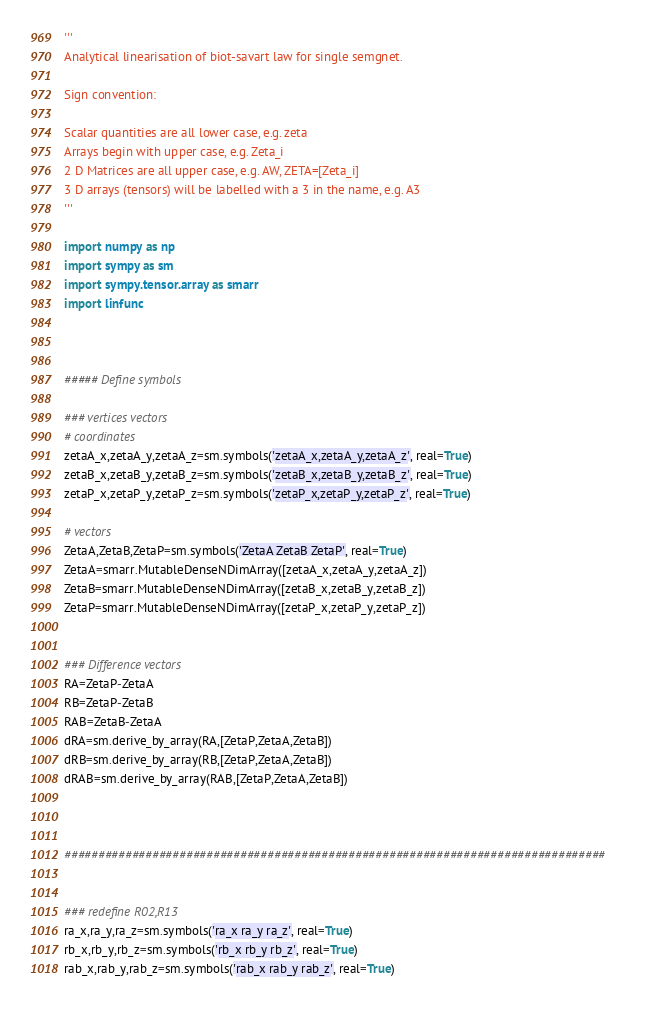Convert code to text. <code><loc_0><loc_0><loc_500><loc_500><_Python_>'''
Analytical linearisation of biot-savart law for single semgnet.

Sign convention:

Scalar quantities are all lower case, e.g. zeta
Arrays begin with upper case, e.g. Zeta_i
2 D Matrices are all upper case, e.g. AW, ZETA=[Zeta_i]
3 D arrays (tensors) will be labelled with a 3 in the name, e.g. A3
'''

import numpy as np
import sympy as sm
import sympy.tensor.array as smarr
import linfunc



##### Define symbols

### vertices vectors
# coordinates
zetaA_x,zetaA_y,zetaA_z=sm.symbols('zetaA_x,zetaA_y,zetaA_z', real=True)
zetaB_x,zetaB_y,zetaB_z=sm.symbols('zetaB_x,zetaB_y,zetaB_z', real=True)
zetaP_x,zetaP_y,zetaP_z=sm.symbols('zetaP_x,zetaP_y,zetaP_z', real=True)

# vectors
ZetaA,ZetaB,ZetaP=sm.symbols('ZetaA ZetaB ZetaP', real=True)
ZetaA=smarr.MutableDenseNDimArray([zetaA_x,zetaA_y,zetaA_z])
ZetaB=smarr.MutableDenseNDimArray([zetaB_x,zetaB_y,zetaB_z])
ZetaP=smarr.MutableDenseNDimArray([zetaP_x,zetaP_y,zetaP_z])


### Difference vectors
RA=ZetaP-ZetaA
RB=ZetaP-ZetaB
RAB=ZetaB-ZetaA
dRA=sm.derive_by_array(RA,[ZetaP,ZetaA,ZetaB])
dRB=sm.derive_by_array(RB,[ZetaP,ZetaA,ZetaB])
dRAB=sm.derive_by_array(RAB,[ZetaP,ZetaA,ZetaB])



################################################################################


### redefine R02,R13
ra_x,ra_y,ra_z=sm.symbols('ra_x ra_y ra_z', real=True)
rb_x,rb_y,rb_z=sm.symbols('rb_x rb_y rb_z', real=True)
rab_x,rab_y,rab_z=sm.symbols('rab_x rab_y rab_z', real=True)</code> 